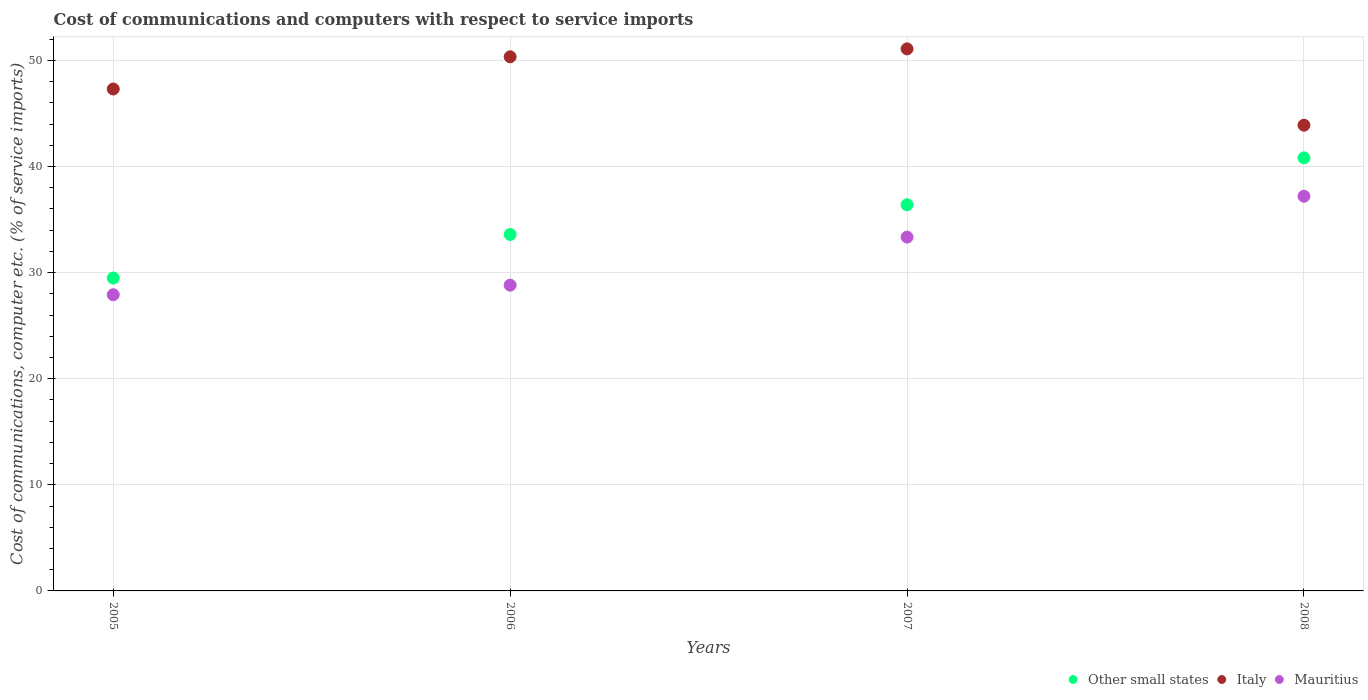How many different coloured dotlines are there?
Keep it short and to the point. 3. What is the cost of communications and computers in Mauritius in 2005?
Provide a succinct answer. 27.91. Across all years, what is the maximum cost of communications and computers in Other small states?
Provide a succinct answer. 40.81. Across all years, what is the minimum cost of communications and computers in Other small states?
Keep it short and to the point. 29.49. In which year was the cost of communications and computers in Other small states maximum?
Offer a terse response. 2008. What is the total cost of communications and computers in Italy in the graph?
Offer a terse response. 192.62. What is the difference between the cost of communications and computers in Italy in 2006 and that in 2007?
Keep it short and to the point. -0.75. What is the difference between the cost of communications and computers in Other small states in 2006 and the cost of communications and computers in Mauritius in 2007?
Your answer should be compact. 0.25. What is the average cost of communications and computers in Other small states per year?
Provide a short and direct response. 35.07. In the year 2005, what is the difference between the cost of communications and computers in Other small states and cost of communications and computers in Italy?
Provide a short and direct response. -17.81. What is the ratio of the cost of communications and computers in Italy in 2007 to that in 2008?
Ensure brevity in your answer.  1.16. What is the difference between the highest and the second highest cost of communications and computers in Mauritius?
Your answer should be very brief. 3.85. What is the difference between the highest and the lowest cost of communications and computers in Other small states?
Provide a short and direct response. 11.33. Is it the case that in every year, the sum of the cost of communications and computers in Mauritius and cost of communications and computers in Other small states  is greater than the cost of communications and computers in Italy?
Your answer should be very brief. Yes. Does the cost of communications and computers in Mauritius monotonically increase over the years?
Make the answer very short. Yes. Is the cost of communications and computers in Italy strictly greater than the cost of communications and computers in Other small states over the years?
Keep it short and to the point. Yes. How many years are there in the graph?
Your answer should be very brief. 4. Does the graph contain grids?
Your response must be concise. Yes. What is the title of the graph?
Keep it short and to the point. Cost of communications and computers with respect to service imports. What is the label or title of the X-axis?
Your answer should be compact. Years. What is the label or title of the Y-axis?
Your answer should be compact. Cost of communications, computer etc. (% of service imports). What is the Cost of communications, computer etc. (% of service imports) in Other small states in 2005?
Your response must be concise. 29.49. What is the Cost of communications, computer etc. (% of service imports) of Italy in 2005?
Provide a short and direct response. 47.3. What is the Cost of communications, computer etc. (% of service imports) of Mauritius in 2005?
Provide a short and direct response. 27.91. What is the Cost of communications, computer etc. (% of service imports) in Other small states in 2006?
Provide a succinct answer. 33.59. What is the Cost of communications, computer etc. (% of service imports) in Italy in 2006?
Keep it short and to the point. 50.34. What is the Cost of communications, computer etc. (% of service imports) in Mauritius in 2006?
Give a very brief answer. 28.82. What is the Cost of communications, computer etc. (% of service imports) of Other small states in 2007?
Your answer should be compact. 36.39. What is the Cost of communications, computer etc. (% of service imports) of Italy in 2007?
Give a very brief answer. 51.08. What is the Cost of communications, computer etc. (% of service imports) of Mauritius in 2007?
Your response must be concise. 33.35. What is the Cost of communications, computer etc. (% of service imports) of Other small states in 2008?
Keep it short and to the point. 40.81. What is the Cost of communications, computer etc. (% of service imports) of Italy in 2008?
Ensure brevity in your answer.  43.89. What is the Cost of communications, computer etc. (% of service imports) of Mauritius in 2008?
Give a very brief answer. 37.2. Across all years, what is the maximum Cost of communications, computer etc. (% of service imports) in Other small states?
Provide a succinct answer. 40.81. Across all years, what is the maximum Cost of communications, computer etc. (% of service imports) in Italy?
Provide a succinct answer. 51.08. Across all years, what is the maximum Cost of communications, computer etc. (% of service imports) in Mauritius?
Give a very brief answer. 37.2. Across all years, what is the minimum Cost of communications, computer etc. (% of service imports) of Other small states?
Give a very brief answer. 29.49. Across all years, what is the minimum Cost of communications, computer etc. (% of service imports) in Italy?
Offer a terse response. 43.89. Across all years, what is the minimum Cost of communications, computer etc. (% of service imports) in Mauritius?
Keep it short and to the point. 27.91. What is the total Cost of communications, computer etc. (% of service imports) in Other small states in the graph?
Offer a terse response. 140.28. What is the total Cost of communications, computer etc. (% of service imports) in Italy in the graph?
Keep it short and to the point. 192.62. What is the total Cost of communications, computer etc. (% of service imports) in Mauritius in the graph?
Provide a succinct answer. 127.27. What is the difference between the Cost of communications, computer etc. (% of service imports) of Other small states in 2005 and that in 2006?
Offer a very short reply. -4.1. What is the difference between the Cost of communications, computer etc. (% of service imports) of Italy in 2005 and that in 2006?
Offer a terse response. -3.04. What is the difference between the Cost of communications, computer etc. (% of service imports) of Mauritius in 2005 and that in 2006?
Provide a short and direct response. -0.9. What is the difference between the Cost of communications, computer etc. (% of service imports) in Other small states in 2005 and that in 2007?
Keep it short and to the point. -6.9. What is the difference between the Cost of communications, computer etc. (% of service imports) of Italy in 2005 and that in 2007?
Make the answer very short. -3.78. What is the difference between the Cost of communications, computer etc. (% of service imports) of Mauritius in 2005 and that in 2007?
Your answer should be very brief. -5.43. What is the difference between the Cost of communications, computer etc. (% of service imports) of Other small states in 2005 and that in 2008?
Your response must be concise. -11.33. What is the difference between the Cost of communications, computer etc. (% of service imports) of Italy in 2005 and that in 2008?
Your response must be concise. 3.41. What is the difference between the Cost of communications, computer etc. (% of service imports) in Mauritius in 2005 and that in 2008?
Give a very brief answer. -9.28. What is the difference between the Cost of communications, computer etc. (% of service imports) in Other small states in 2006 and that in 2007?
Offer a terse response. -2.8. What is the difference between the Cost of communications, computer etc. (% of service imports) in Italy in 2006 and that in 2007?
Provide a succinct answer. -0.75. What is the difference between the Cost of communications, computer etc. (% of service imports) in Mauritius in 2006 and that in 2007?
Provide a short and direct response. -4.53. What is the difference between the Cost of communications, computer etc. (% of service imports) in Other small states in 2006 and that in 2008?
Keep it short and to the point. -7.22. What is the difference between the Cost of communications, computer etc. (% of service imports) of Italy in 2006 and that in 2008?
Provide a short and direct response. 6.45. What is the difference between the Cost of communications, computer etc. (% of service imports) of Mauritius in 2006 and that in 2008?
Offer a very short reply. -8.38. What is the difference between the Cost of communications, computer etc. (% of service imports) of Other small states in 2007 and that in 2008?
Your response must be concise. -4.42. What is the difference between the Cost of communications, computer etc. (% of service imports) in Italy in 2007 and that in 2008?
Make the answer very short. 7.19. What is the difference between the Cost of communications, computer etc. (% of service imports) in Mauritius in 2007 and that in 2008?
Your response must be concise. -3.85. What is the difference between the Cost of communications, computer etc. (% of service imports) in Other small states in 2005 and the Cost of communications, computer etc. (% of service imports) in Italy in 2006?
Your answer should be very brief. -20.85. What is the difference between the Cost of communications, computer etc. (% of service imports) of Other small states in 2005 and the Cost of communications, computer etc. (% of service imports) of Mauritius in 2006?
Provide a short and direct response. 0.67. What is the difference between the Cost of communications, computer etc. (% of service imports) in Italy in 2005 and the Cost of communications, computer etc. (% of service imports) in Mauritius in 2006?
Your answer should be compact. 18.49. What is the difference between the Cost of communications, computer etc. (% of service imports) of Other small states in 2005 and the Cost of communications, computer etc. (% of service imports) of Italy in 2007?
Your response must be concise. -21.6. What is the difference between the Cost of communications, computer etc. (% of service imports) in Other small states in 2005 and the Cost of communications, computer etc. (% of service imports) in Mauritius in 2007?
Ensure brevity in your answer.  -3.86. What is the difference between the Cost of communications, computer etc. (% of service imports) in Italy in 2005 and the Cost of communications, computer etc. (% of service imports) in Mauritius in 2007?
Ensure brevity in your answer.  13.96. What is the difference between the Cost of communications, computer etc. (% of service imports) of Other small states in 2005 and the Cost of communications, computer etc. (% of service imports) of Italy in 2008?
Ensure brevity in your answer.  -14.4. What is the difference between the Cost of communications, computer etc. (% of service imports) of Other small states in 2005 and the Cost of communications, computer etc. (% of service imports) of Mauritius in 2008?
Offer a terse response. -7.71. What is the difference between the Cost of communications, computer etc. (% of service imports) of Italy in 2005 and the Cost of communications, computer etc. (% of service imports) of Mauritius in 2008?
Offer a terse response. 10.11. What is the difference between the Cost of communications, computer etc. (% of service imports) of Other small states in 2006 and the Cost of communications, computer etc. (% of service imports) of Italy in 2007?
Provide a succinct answer. -17.49. What is the difference between the Cost of communications, computer etc. (% of service imports) in Other small states in 2006 and the Cost of communications, computer etc. (% of service imports) in Mauritius in 2007?
Give a very brief answer. 0.25. What is the difference between the Cost of communications, computer etc. (% of service imports) of Italy in 2006 and the Cost of communications, computer etc. (% of service imports) of Mauritius in 2007?
Offer a terse response. 16.99. What is the difference between the Cost of communications, computer etc. (% of service imports) of Other small states in 2006 and the Cost of communications, computer etc. (% of service imports) of Italy in 2008?
Your response must be concise. -10.3. What is the difference between the Cost of communications, computer etc. (% of service imports) in Other small states in 2006 and the Cost of communications, computer etc. (% of service imports) in Mauritius in 2008?
Make the answer very short. -3.6. What is the difference between the Cost of communications, computer etc. (% of service imports) of Italy in 2006 and the Cost of communications, computer etc. (% of service imports) of Mauritius in 2008?
Your answer should be compact. 13.14. What is the difference between the Cost of communications, computer etc. (% of service imports) of Other small states in 2007 and the Cost of communications, computer etc. (% of service imports) of Italy in 2008?
Your response must be concise. -7.5. What is the difference between the Cost of communications, computer etc. (% of service imports) in Other small states in 2007 and the Cost of communications, computer etc. (% of service imports) in Mauritius in 2008?
Offer a very short reply. -0.8. What is the difference between the Cost of communications, computer etc. (% of service imports) of Italy in 2007 and the Cost of communications, computer etc. (% of service imports) of Mauritius in 2008?
Your answer should be very brief. 13.89. What is the average Cost of communications, computer etc. (% of service imports) of Other small states per year?
Your answer should be very brief. 35.07. What is the average Cost of communications, computer etc. (% of service imports) in Italy per year?
Keep it short and to the point. 48.15. What is the average Cost of communications, computer etc. (% of service imports) in Mauritius per year?
Your answer should be very brief. 31.82. In the year 2005, what is the difference between the Cost of communications, computer etc. (% of service imports) of Other small states and Cost of communications, computer etc. (% of service imports) of Italy?
Provide a succinct answer. -17.81. In the year 2005, what is the difference between the Cost of communications, computer etc. (% of service imports) of Other small states and Cost of communications, computer etc. (% of service imports) of Mauritius?
Keep it short and to the point. 1.57. In the year 2005, what is the difference between the Cost of communications, computer etc. (% of service imports) in Italy and Cost of communications, computer etc. (% of service imports) in Mauritius?
Keep it short and to the point. 19.39. In the year 2006, what is the difference between the Cost of communications, computer etc. (% of service imports) in Other small states and Cost of communications, computer etc. (% of service imports) in Italy?
Your answer should be compact. -16.75. In the year 2006, what is the difference between the Cost of communications, computer etc. (% of service imports) in Other small states and Cost of communications, computer etc. (% of service imports) in Mauritius?
Offer a terse response. 4.78. In the year 2006, what is the difference between the Cost of communications, computer etc. (% of service imports) in Italy and Cost of communications, computer etc. (% of service imports) in Mauritius?
Offer a terse response. 21.52. In the year 2007, what is the difference between the Cost of communications, computer etc. (% of service imports) in Other small states and Cost of communications, computer etc. (% of service imports) in Italy?
Ensure brevity in your answer.  -14.69. In the year 2007, what is the difference between the Cost of communications, computer etc. (% of service imports) of Other small states and Cost of communications, computer etc. (% of service imports) of Mauritius?
Your answer should be compact. 3.05. In the year 2007, what is the difference between the Cost of communications, computer etc. (% of service imports) of Italy and Cost of communications, computer etc. (% of service imports) of Mauritius?
Your answer should be very brief. 17.74. In the year 2008, what is the difference between the Cost of communications, computer etc. (% of service imports) in Other small states and Cost of communications, computer etc. (% of service imports) in Italy?
Make the answer very short. -3.08. In the year 2008, what is the difference between the Cost of communications, computer etc. (% of service imports) in Other small states and Cost of communications, computer etc. (% of service imports) in Mauritius?
Ensure brevity in your answer.  3.62. In the year 2008, what is the difference between the Cost of communications, computer etc. (% of service imports) in Italy and Cost of communications, computer etc. (% of service imports) in Mauritius?
Provide a short and direct response. 6.7. What is the ratio of the Cost of communications, computer etc. (% of service imports) of Other small states in 2005 to that in 2006?
Offer a terse response. 0.88. What is the ratio of the Cost of communications, computer etc. (% of service imports) of Italy in 2005 to that in 2006?
Your response must be concise. 0.94. What is the ratio of the Cost of communications, computer etc. (% of service imports) of Mauritius in 2005 to that in 2006?
Keep it short and to the point. 0.97. What is the ratio of the Cost of communications, computer etc. (% of service imports) of Other small states in 2005 to that in 2007?
Make the answer very short. 0.81. What is the ratio of the Cost of communications, computer etc. (% of service imports) of Italy in 2005 to that in 2007?
Offer a very short reply. 0.93. What is the ratio of the Cost of communications, computer etc. (% of service imports) of Mauritius in 2005 to that in 2007?
Your answer should be very brief. 0.84. What is the ratio of the Cost of communications, computer etc. (% of service imports) in Other small states in 2005 to that in 2008?
Provide a short and direct response. 0.72. What is the ratio of the Cost of communications, computer etc. (% of service imports) in Italy in 2005 to that in 2008?
Provide a short and direct response. 1.08. What is the ratio of the Cost of communications, computer etc. (% of service imports) in Mauritius in 2005 to that in 2008?
Your answer should be compact. 0.75. What is the ratio of the Cost of communications, computer etc. (% of service imports) of Other small states in 2006 to that in 2007?
Your answer should be compact. 0.92. What is the ratio of the Cost of communications, computer etc. (% of service imports) of Italy in 2006 to that in 2007?
Give a very brief answer. 0.99. What is the ratio of the Cost of communications, computer etc. (% of service imports) in Mauritius in 2006 to that in 2007?
Offer a very short reply. 0.86. What is the ratio of the Cost of communications, computer etc. (% of service imports) of Other small states in 2006 to that in 2008?
Ensure brevity in your answer.  0.82. What is the ratio of the Cost of communications, computer etc. (% of service imports) of Italy in 2006 to that in 2008?
Keep it short and to the point. 1.15. What is the ratio of the Cost of communications, computer etc. (% of service imports) in Mauritius in 2006 to that in 2008?
Your answer should be compact. 0.77. What is the ratio of the Cost of communications, computer etc. (% of service imports) in Other small states in 2007 to that in 2008?
Your response must be concise. 0.89. What is the ratio of the Cost of communications, computer etc. (% of service imports) in Italy in 2007 to that in 2008?
Ensure brevity in your answer.  1.16. What is the ratio of the Cost of communications, computer etc. (% of service imports) of Mauritius in 2007 to that in 2008?
Offer a very short reply. 0.9. What is the difference between the highest and the second highest Cost of communications, computer etc. (% of service imports) of Other small states?
Ensure brevity in your answer.  4.42. What is the difference between the highest and the second highest Cost of communications, computer etc. (% of service imports) in Italy?
Provide a succinct answer. 0.75. What is the difference between the highest and the second highest Cost of communications, computer etc. (% of service imports) in Mauritius?
Your answer should be compact. 3.85. What is the difference between the highest and the lowest Cost of communications, computer etc. (% of service imports) in Other small states?
Ensure brevity in your answer.  11.33. What is the difference between the highest and the lowest Cost of communications, computer etc. (% of service imports) of Italy?
Your answer should be very brief. 7.19. What is the difference between the highest and the lowest Cost of communications, computer etc. (% of service imports) in Mauritius?
Your response must be concise. 9.28. 